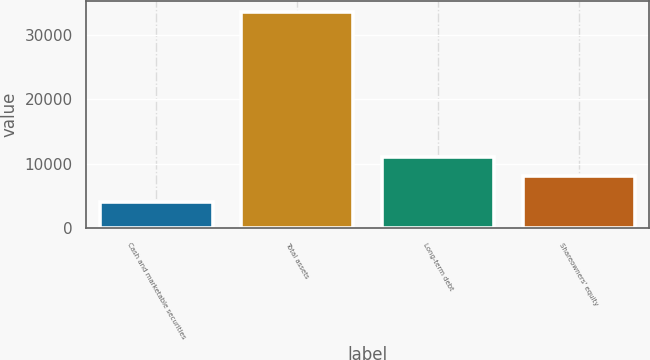Convert chart to OTSL. <chart><loc_0><loc_0><loc_500><loc_500><bar_chart><fcel>Cash and marketable securities<fcel>Total assets<fcel>Long-term debt<fcel>Shareowners' equity<nl><fcel>4081<fcel>33597<fcel>10998.6<fcel>8047<nl></chart> 